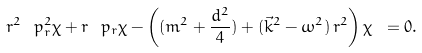<formula> <loc_0><loc_0><loc_500><loc_500>r ^ { 2 } \, \ p _ { r } ^ { 2 } \chi + r \, \ p _ { r } \chi - \left ( ( m ^ { 2 } + \frac { d ^ { 2 } } { 4 } ) + ( \vec { k } ^ { 2 } - \omega ^ { 2 } ) \, r ^ { 2 } \right ) \chi \ = 0 .</formula> 